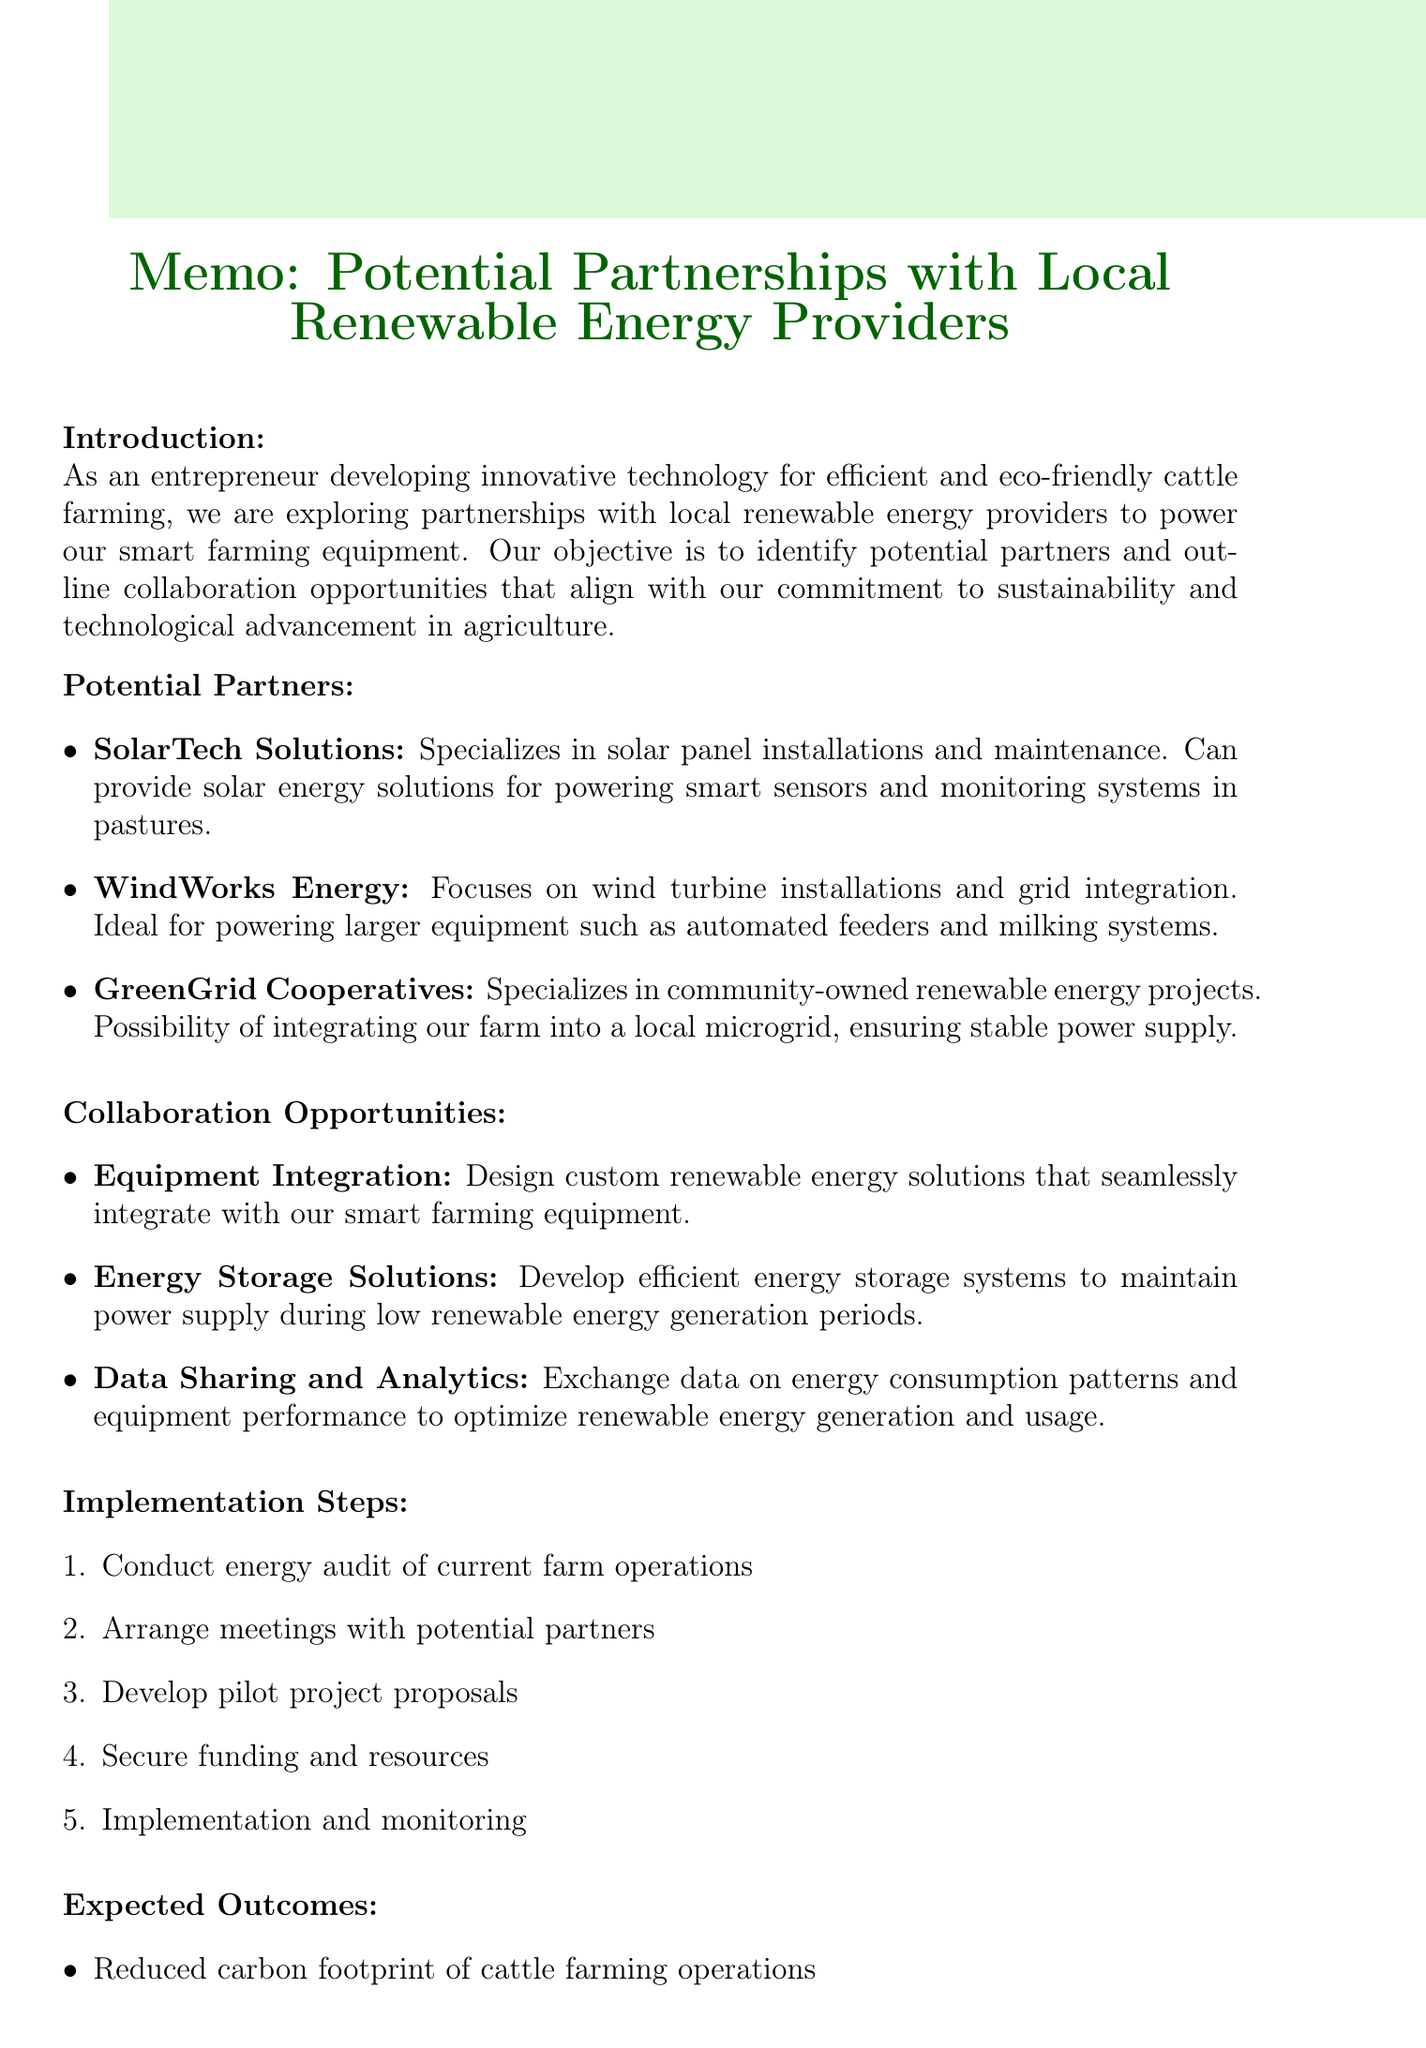What is the title of the memo? The title of the memo is provided at the beginning of the document.
Answer: Potential Partnerships with Local Renewable Energy Providers for Smart Farming Equipment Who is a potential partner that specializes in solar energy? The document lists potential partners and their specializations, including SolarTech Solutions.
Answer: SolarTech Solutions What is one collaboration opportunity mentioned in the memo? The memo outlines several collaboration opportunities such as Equipment Integration.
Answer: Equipment Integration How many steps are in the implementation plan? The implementation steps are outlined in a numbered list in the document.
Answer: 5 What benefit does energy storage solutions provide? The document states the benefit of energy storage solutions in terms of system reliability.
Answer: Increases reliability of our smart farming systems What is one expected outcome of the partnerships? The memo outlines expected outcomes, including reduced carbon footprint.
Answer: Reduced carbon footprint of cattle farming operations What type of energy provider is GreenGrid Cooperatives? The document categorizes GreenGrid Cooperatives based on its specialization in the context of renewable energy projects.
Answer: Community-owned renewable energy projects What is the first step of implementation? The implementation steps are detailed in the document, starting with conducting an energy audit.
Answer: Conduct energy audit of current farm operations 